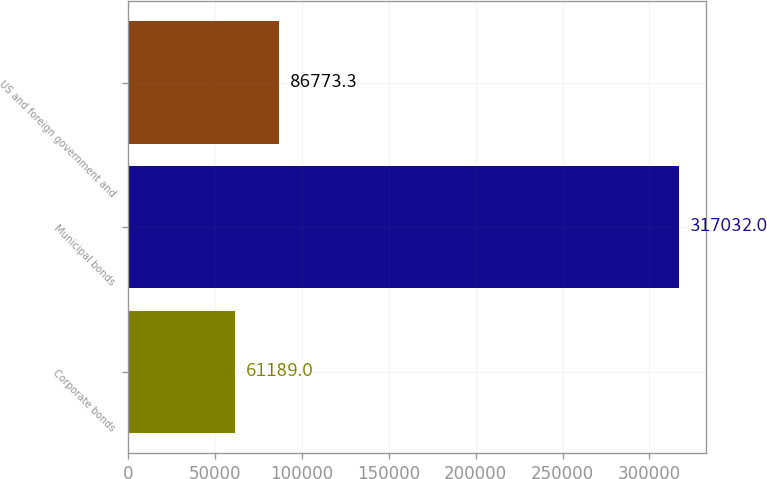Convert chart. <chart><loc_0><loc_0><loc_500><loc_500><bar_chart><fcel>Corporate bonds<fcel>Municipal bonds<fcel>US and foreign government and<nl><fcel>61189<fcel>317032<fcel>86773.3<nl></chart> 